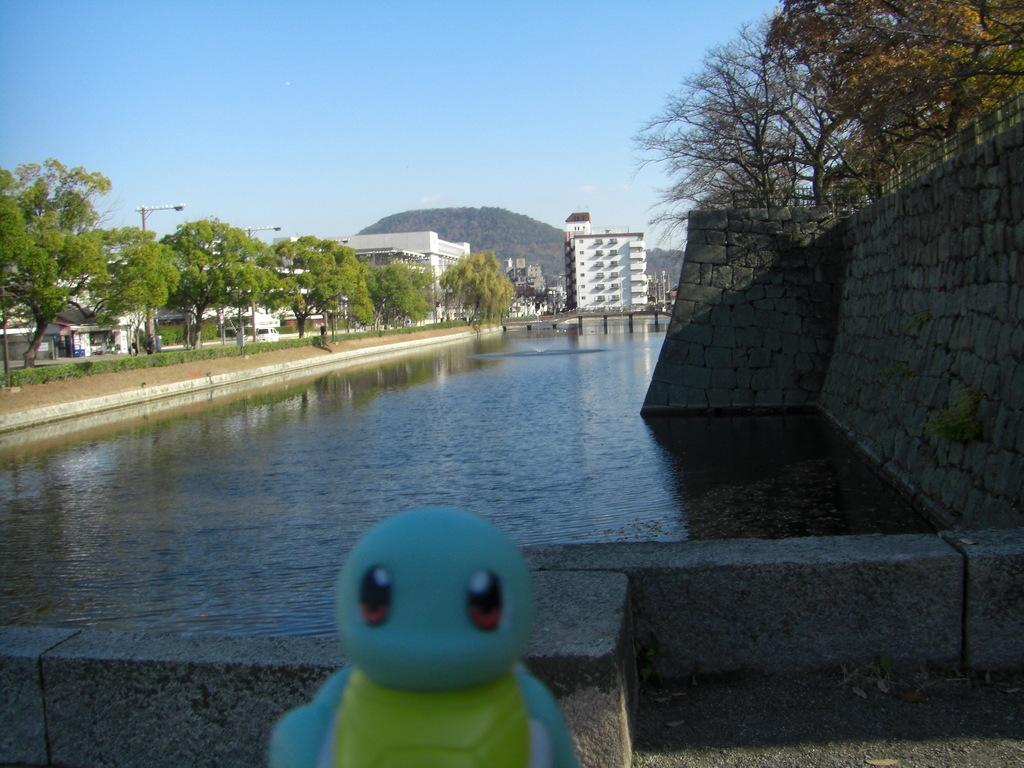What type of natural environment is depicted in the image? The image contains many trees, water, grass, and a mountain, indicating a natural environment. What type of man-made structures can be seen in the image? There are buildings and a light pole in the image. What type of terrain is visible in the image? The image contains a mountain, suggesting a hilly or mountainous terrain. What type of object can be seen in the image that is not related to the natural environment or man-made structures? There is a toy in the image. What type of barrier is present in the image? There is a stone wall in the image. What type of blade is being used to cut the grass in the image? There is no blade visible in the image, as the grass appears to be natural and not cut. 